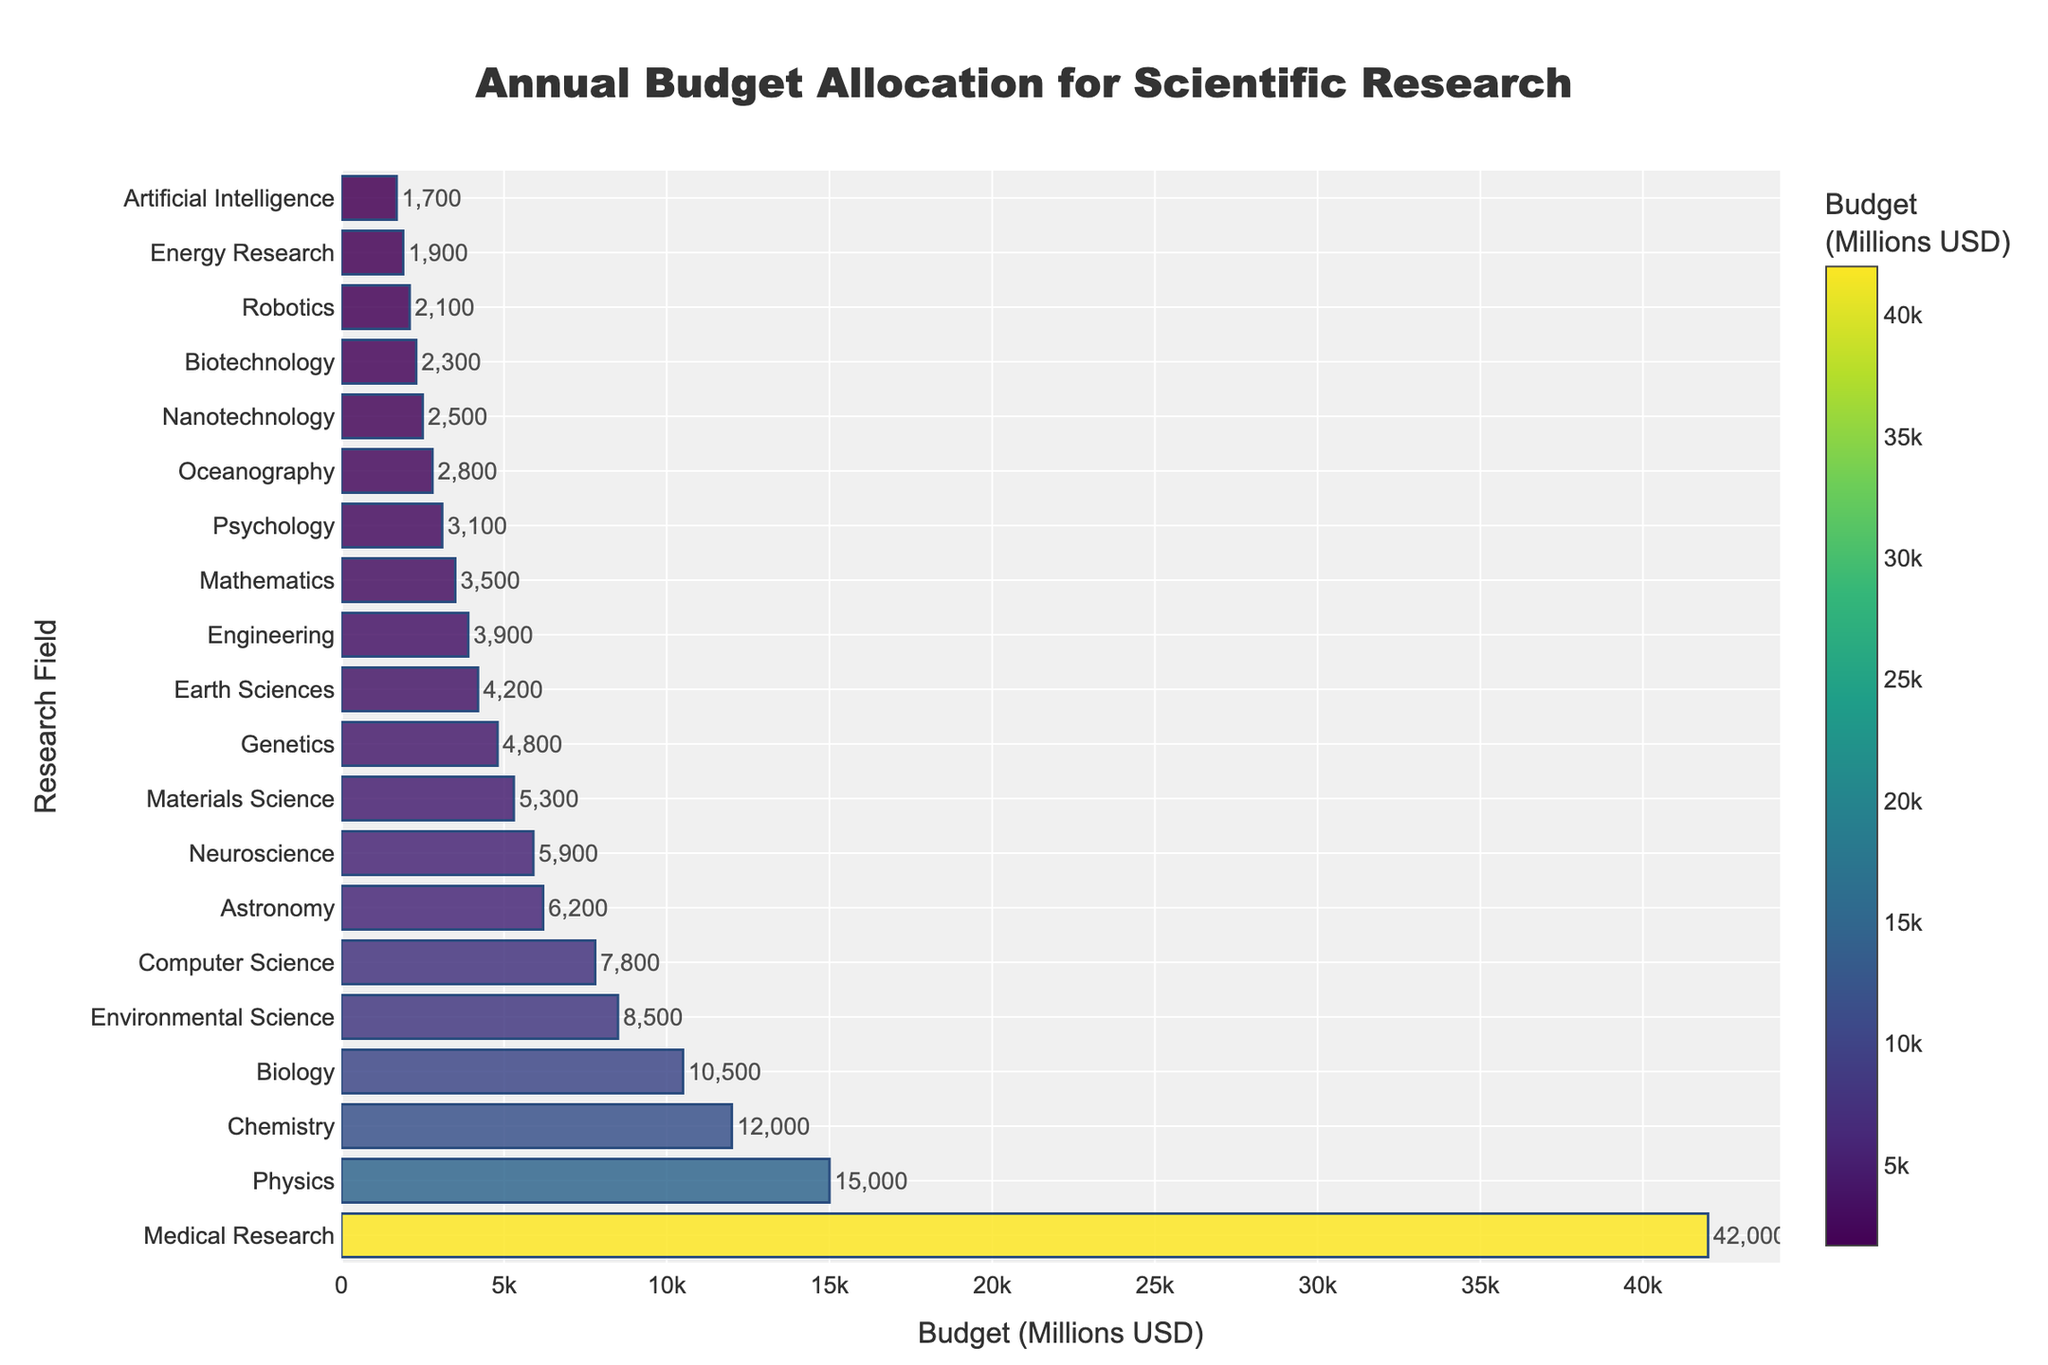What is the field with the highest budget allocation? To find the field with the highest budget allocation, simply observe which bar is the longest or has the highest value on the chart. The field with the longest bar is Medical Research.
Answer: Medical Research How much more budget does Medical Research have compared to Physics? First, find the budget for both fields from the chart: Medical Research has $42,000 million and Physics has $15,000 million. Then, subtract the Physics budget from the Medical Research budget: $42,000 million - $15,000 million = $27,000 million.
Answer: $27,000 million What is the total budget allocated to Biology, Environmental Science, and Computer Science combined? To find the total budget for these three fields, sum their respective budgets from the chart: Biology ($10,500 million) + Environmental Science ($8,500 million) + Computer Science ($7,800 million). This equates to $10,500 million + $8,500 million + $7,800 million = $26,800 million.
Answer: $26,800 million Is the budget for Neuroscience greater or less than the budget for Astronomy? Compare the budget values for Neuroscience and Astronomy from the chart. Neuroscience has a budget of $5,900 million, and Astronomy has a budget of $6,200 million. Since $5,900 million < $6,200 million, the budget for Neuroscience is less.
Answer: Less Which research field has the smallest budget allocation? To identify the field with the smallest budget allocation, look for the shortest bar on the chart. The shortest bar corresponds to Artificial Intelligence with a budget of $1,700 million.
Answer: Artificial Intelligence How does the budget for Materials Science compare to that of Genetics? Compare the lengths of the bars or the budgets from the chart. Materials Science has a budget of $5,300 million, while Genetics has a budget of $4,800 million. Since $5,300 million > $4,800 million, Materials Science has a higher budget.
Answer: Higher What is the difference in budget allocations between the highest-funded and lowest-funded fields? Identify the highest and lowest budget fields from the chart: Medical Research ($42,000 million) and Artificial Intelligence ($1,700 million). Calculate the difference: $42,000 million - $1,700 million = $40,300 million.
Answer: $40,300 million Which fields have a budget allocation greater than $10,000 million? To answer this, observe the bars that extend beyond the $10,000 million mark on the chart. Fields with budgets greater than $10,000 million are Medical Research, Physics, Chemistry, and Biology.
Answer: Medical Research, Physics, Chemistry, Biology What is the average budget allocation for the fields listed? To calculate the average budget, sum all the budget allocations and divide by the number of fields. The total budget sum is 42,000+15,000+12,000+10,500+8,500+7,800+6,200+5,900+5,300+4,800+4,200+3,900+3,500+3,100+2,800+2,500+2,300+2,100+1,900+1,700 = 153,000 million USD and there are 20 fields. So, the average budget is 153,000 / 20 = 7,650 million USD.
Answer: 7,650 million USD 